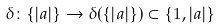<formula> <loc_0><loc_0><loc_500><loc_500>\delta \colon \{ | a | \} \to \delta ( \{ | a | \} ) \subset \{ 1 , | a | \}</formula> 